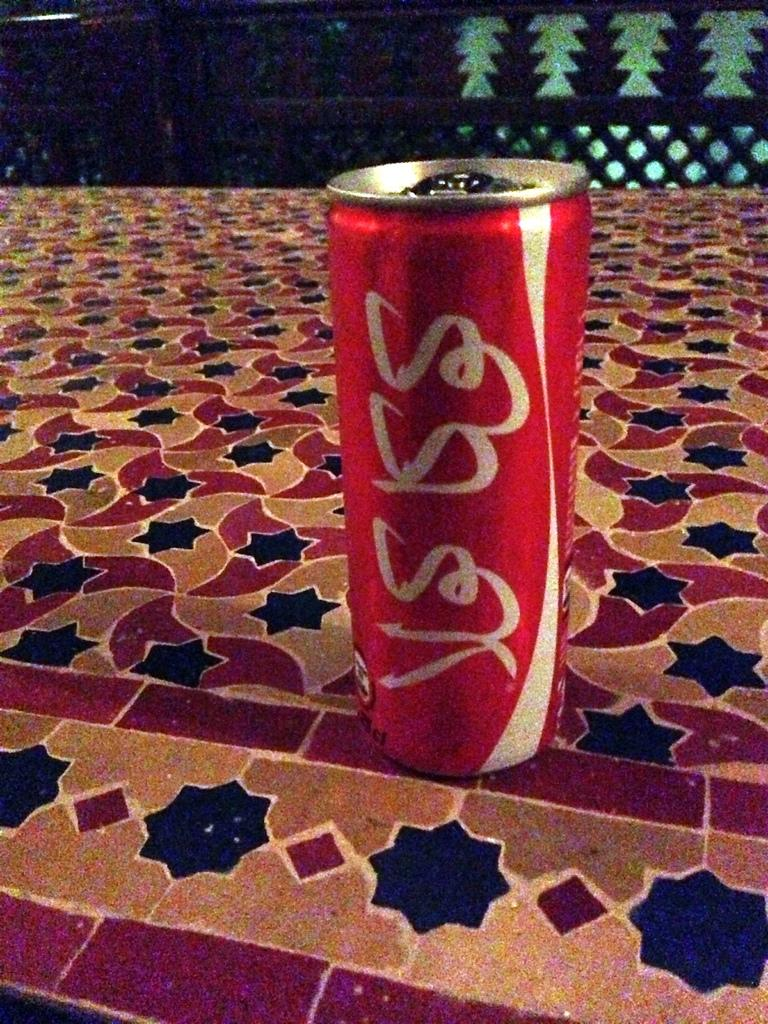<image>
Share a concise interpretation of the image provided. The writing on the red can is in a foreign language 